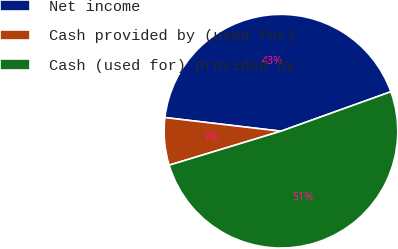Convert chart to OTSL. <chart><loc_0><loc_0><loc_500><loc_500><pie_chart><fcel>Net income<fcel>Cash provided by (used for)<fcel>Cash (used for) provided by<nl><fcel>42.65%<fcel>6.56%<fcel>50.79%<nl></chart> 